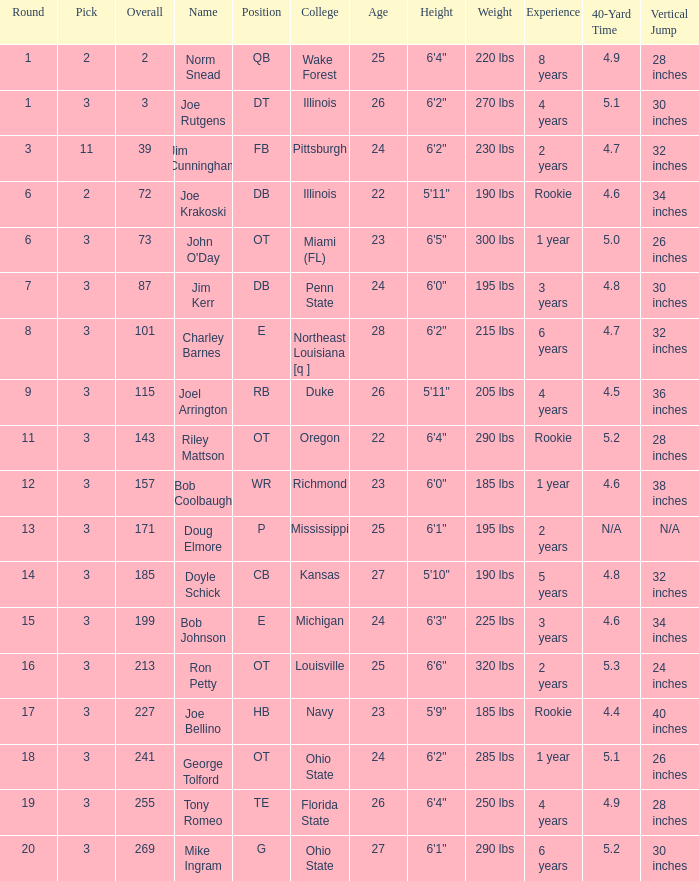How many rounds have john o'day as the name, and a pick less than 3? None. Could you parse the entire table as a dict? {'header': ['Round', 'Pick', 'Overall', 'Name', 'Position', 'College', 'Age', 'Height', 'Weight', 'Experience', '40-Yard Time', 'Vertical Jump'], 'rows': [['1', '2', '2', 'Norm Snead', 'QB', 'Wake Forest', '25', '6\'4"', '220 lbs', '8 years', '4.9', '28 inches'], ['1', '3', '3', 'Joe Rutgens', 'DT', 'Illinois', '26', '6\'2"', '270 lbs', '4 years', '5.1', '30 inches'], ['3', '11', '39', 'Jim Cunningham', 'FB', 'Pittsburgh', '24', '6\'2"', '230 lbs', '2 years', '4.7', '32 inches'], ['6', '2', '72', 'Joe Krakoski', 'DB', 'Illinois', '22', '5\'11"', '190 lbs', 'Rookie', '4.6', '34 inches'], ['6', '3', '73', "John O'Day", 'OT', 'Miami (FL)', '23', '6\'5"', '300 lbs', '1 year', '5.0', '26 inches'], ['7', '3', '87', 'Jim Kerr', 'DB', 'Penn State', '24', '6\'0"', '195 lbs', '3 years', '4.8', '30 inches'], ['8', '3', '101', 'Charley Barnes', 'E', 'Northeast Louisiana [q ]', '28', '6\'2"', '215 lbs', '6 years', '4.7', '32 inches'], ['9', '3', '115', 'Joel Arrington', 'RB', 'Duke', '26', '5\'11"', '205 lbs', '4 years', '4.5', '36 inches'], ['11', '3', '143', 'Riley Mattson', 'OT', 'Oregon', '22', '6\'4"', '290 lbs', 'Rookie', '5.2', '28 inches'], ['12', '3', '157', 'Bob Coolbaugh', 'WR', 'Richmond', '23', '6\'0"', '185 lbs', '1 year', '4.6', '38 inches'], ['13', '3', '171', 'Doug Elmore', 'P', 'Mississippi', '25', '6\'1"', '195 lbs', '2 years', 'N/A', 'N/A'], ['14', '3', '185', 'Doyle Schick', 'CB', 'Kansas', '27', '5\'10"', '190 lbs', '5 years', '4.8', '32 inches'], ['15', '3', '199', 'Bob Johnson', 'E', 'Michigan', '24', '6\'3"', '225 lbs', '3 years', '4.6', '34 inches'], ['16', '3', '213', 'Ron Petty', 'OT', 'Louisville', '25', '6\'6"', '320 lbs', '2 years', '5.3', '24 inches'], ['17', '3', '227', 'Joe Bellino', 'HB', 'Navy', '23', '5\'9"', '185 lbs', 'Rookie', '4.4', '40 inches'], ['18', '3', '241', 'George Tolford', 'OT', 'Ohio State', '24', '6\'2"', '285 lbs', '1 year', '5.1', '26 inches'], ['19', '3', '255', 'Tony Romeo', 'TE', 'Florida State', '26', '6\'4"', '250 lbs', '4 years', '4.9', '28 inches'], ['20', '3', '269', 'Mike Ingram', 'G', 'Ohio State', '27', '6\'1"', '290 lbs', '6 years', '5.2', '30 inches']]} 